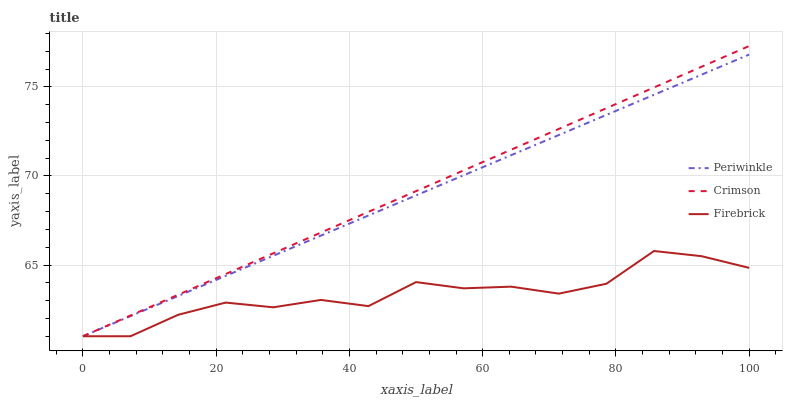Does Firebrick have the minimum area under the curve?
Answer yes or no. Yes. Does Crimson have the maximum area under the curve?
Answer yes or no. Yes. Does Periwinkle have the minimum area under the curve?
Answer yes or no. No. Does Periwinkle have the maximum area under the curve?
Answer yes or no. No. Is Periwinkle the smoothest?
Answer yes or no. Yes. Is Firebrick the roughest?
Answer yes or no. Yes. Is Firebrick the smoothest?
Answer yes or no. No. Is Periwinkle the roughest?
Answer yes or no. No. Does Periwinkle have the highest value?
Answer yes or no. No. 